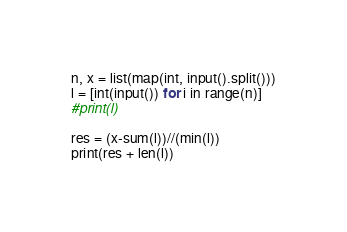Convert code to text. <code><loc_0><loc_0><loc_500><loc_500><_Python_>n, x = list(map(int, input().split()))
l = [int(input()) for i in range(n)]
#print(l)

res = (x-sum(l))//(min(l))
print(res + len(l))</code> 